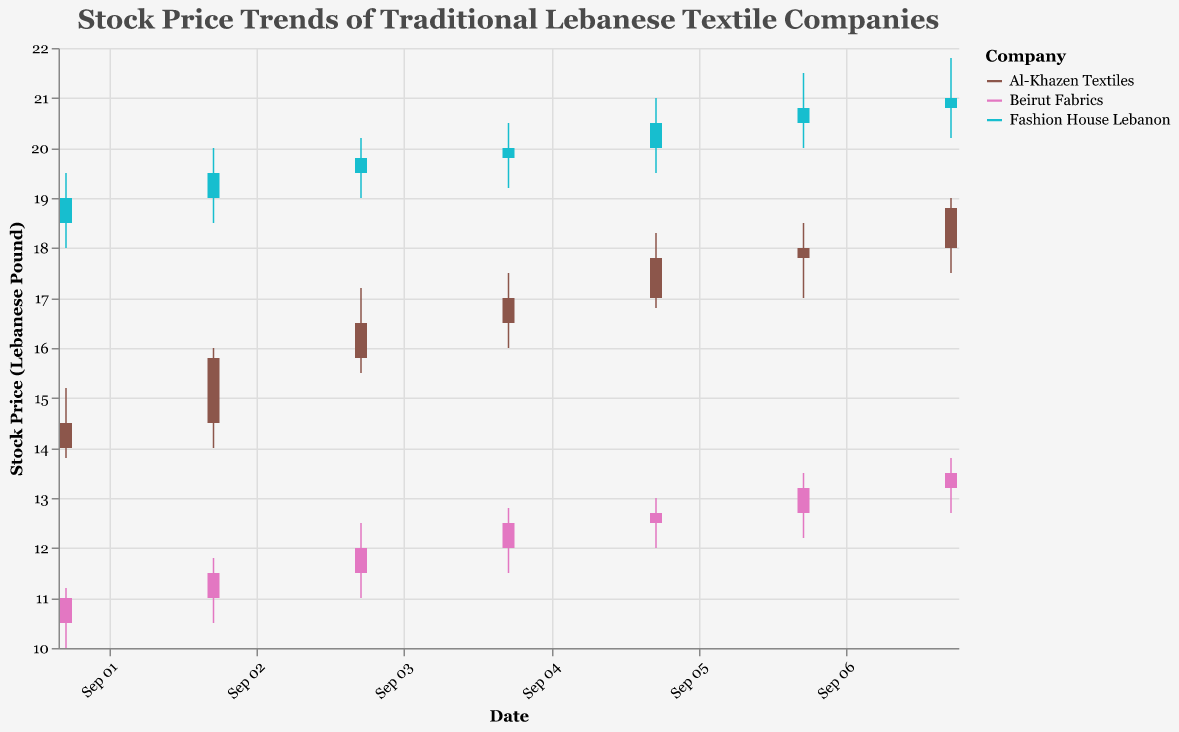What is the title of the plot? The title of the plot is located at the top of the figure and describes the main topic of the visualization.
Answer: Stock Price Trends of Traditional Lebanese Textile Companies Between which dates does the plot show data? The x-axis shows the date range, with labels formatted as months and days. From the beginning to the end of the plot, the dates range from September 1 to September 7, 2023.
Answer: September 1, 2023 to September 7, 2023 Which company has the highest closing stock price on September 3, 2023? By looking at the candlestick data for September 3, 2023, and comparing the closing prices, Fashion House Lebanon shows the highest closing price among the companies.
Answer: Fashion House Lebanon By how much did the closing stock price for Al-Khazen Textiles change from September 1 to September 7, 2023? First, look at the closing prices of Al-Khazen Textiles on both dates, which are 14.5 on September 1 and 18.8 on September 7. Subtract the September 1 price from the September 7 price: 18.8 - 14.5 = 4.3.
Answer: 4.3 Which company had the most volatile stock price over the given period? By comparing the high and low prices for each company throughout the period, Fashion House Lebanon shows the widest range of price movements (from 18.0 to 21.8).
Answer: Fashion House Lebanon What was the average closing price for Beirut Fabrics from September 1 to September 7, 2023? Add the daily closing prices for Beirut Fabrics: 11.0 + 11.5 + 12.0 + 12.5 + 12.7 + 13.2 + 13.5 = 86.4, and then divide by the number of days: 86.4 / 7 = 12.34.
Answer: 12.34 Compare the trading volumes of Al-Khazen Textiles and Fashion House Lebanon on September 5, 2023. Look at the volume data for both companies on September 5. Al-Khazen Textiles has a volume of 1650, and Fashion House Lebanon has a volume of 1350. Therefore, Al-Khazen Textiles had a higher trading volume.
Answer: Al-Khazen Textiles Which day had the highest closing stock price for all companies combined? By identifying the highest closing price for each company and then checking the respective days, September 7 shows a closing price of 18.8 for Al-Khazen Textiles, 13.5 for Beirut Fabrics, and 21.0 for Fashion House Lebanon, the sum is 53.3.
Answer: September 7 Which company had the least variation between its high and low prices on September 2, 2023? Compare the difference between the high and low prices for each company on that date. Beirut Fabrics shows the least variation with a range from 10.5 to 11.8 (difference of 1.3).
Answer: Beirut Fabrics 